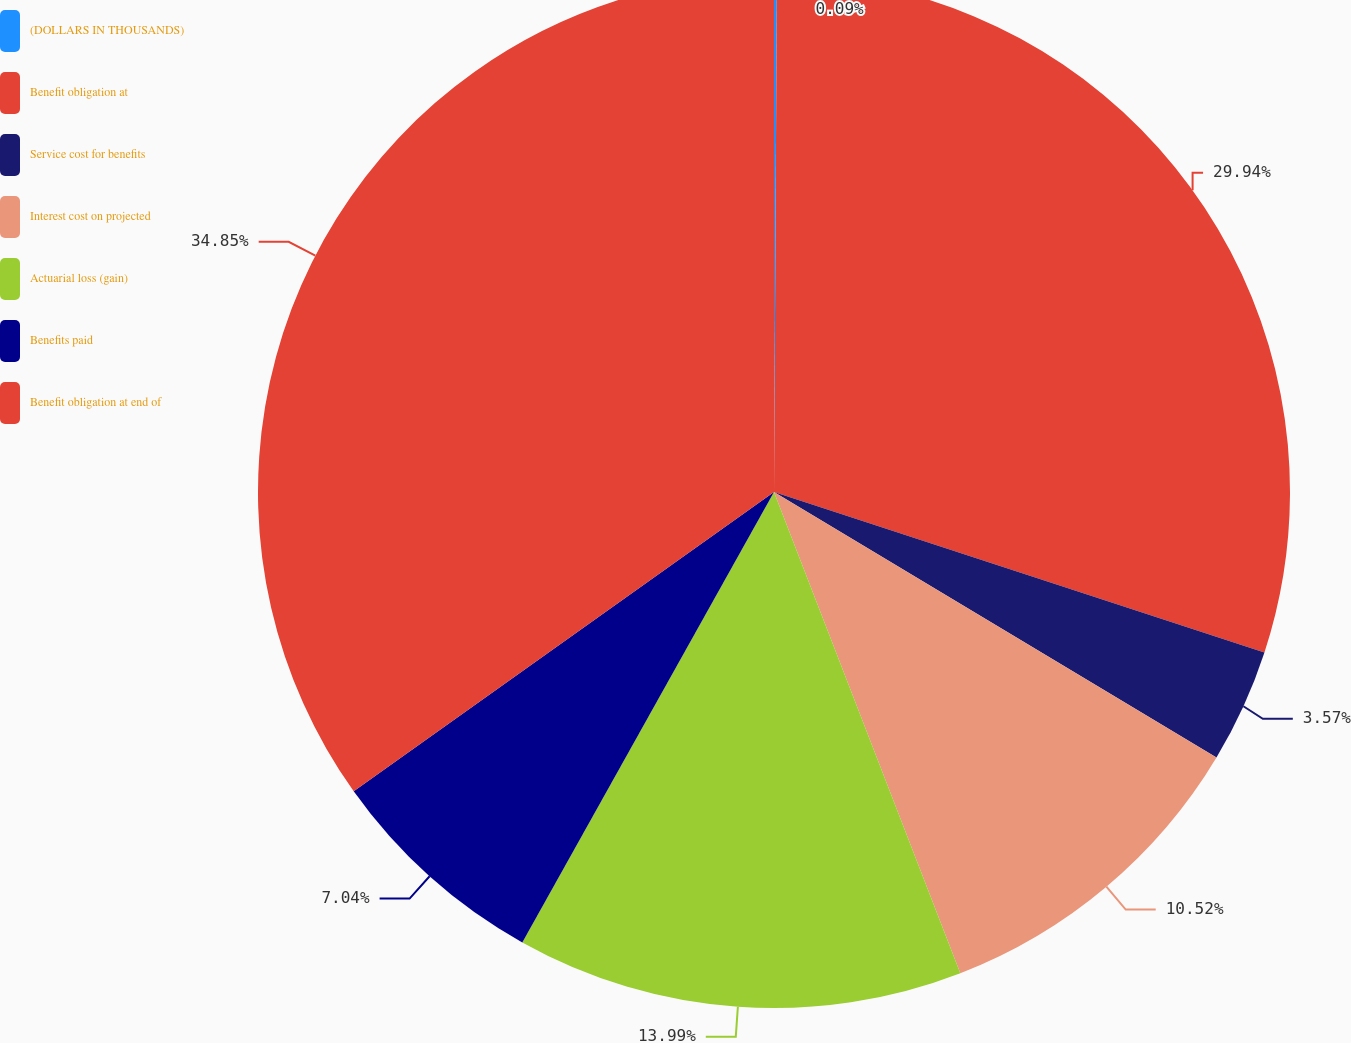Convert chart to OTSL. <chart><loc_0><loc_0><loc_500><loc_500><pie_chart><fcel>(DOLLARS IN THOUSANDS)<fcel>Benefit obligation at<fcel>Service cost for benefits<fcel>Interest cost on projected<fcel>Actuarial loss (gain)<fcel>Benefits paid<fcel>Benefit obligation at end of<nl><fcel>0.09%<fcel>29.94%<fcel>3.57%<fcel>10.52%<fcel>13.99%<fcel>7.04%<fcel>34.85%<nl></chart> 